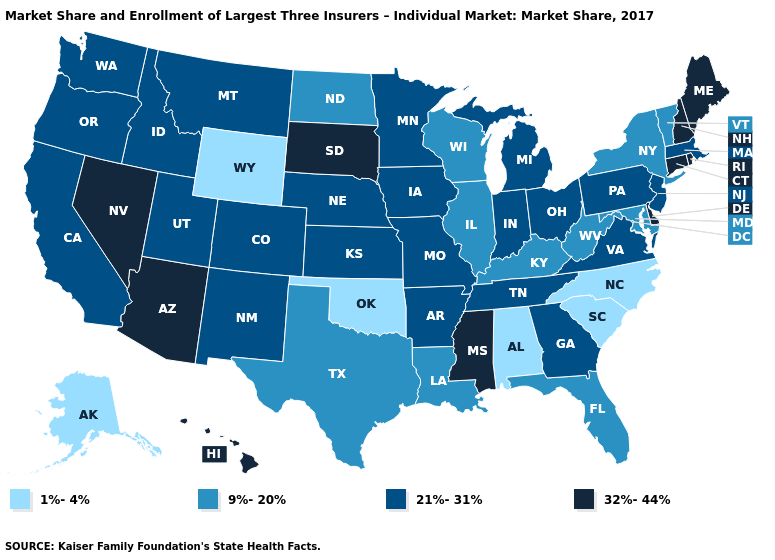Does the map have missing data?
Quick response, please. No. What is the value of Wisconsin?
Answer briefly. 9%-20%. What is the value of New Jersey?
Answer briefly. 21%-31%. Name the states that have a value in the range 32%-44%?
Be succinct. Arizona, Connecticut, Delaware, Hawaii, Maine, Mississippi, Nevada, New Hampshire, Rhode Island, South Dakota. What is the lowest value in states that border Delaware?
Be succinct. 9%-20%. Does the map have missing data?
Keep it brief. No. Which states have the highest value in the USA?
Concise answer only. Arizona, Connecticut, Delaware, Hawaii, Maine, Mississippi, Nevada, New Hampshire, Rhode Island, South Dakota. How many symbols are there in the legend?
Concise answer only. 4. Name the states that have a value in the range 9%-20%?
Give a very brief answer. Florida, Illinois, Kentucky, Louisiana, Maryland, New York, North Dakota, Texas, Vermont, West Virginia, Wisconsin. Which states hav the highest value in the Northeast?
Concise answer only. Connecticut, Maine, New Hampshire, Rhode Island. What is the value of South Dakota?
Short answer required. 32%-44%. Among the states that border Utah , which have the highest value?
Give a very brief answer. Arizona, Nevada. What is the value of Nevada?
Concise answer only. 32%-44%. Does Missouri have the lowest value in the MidWest?
Answer briefly. No. What is the lowest value in the South?
Write a very short answer. 1%-4%. 